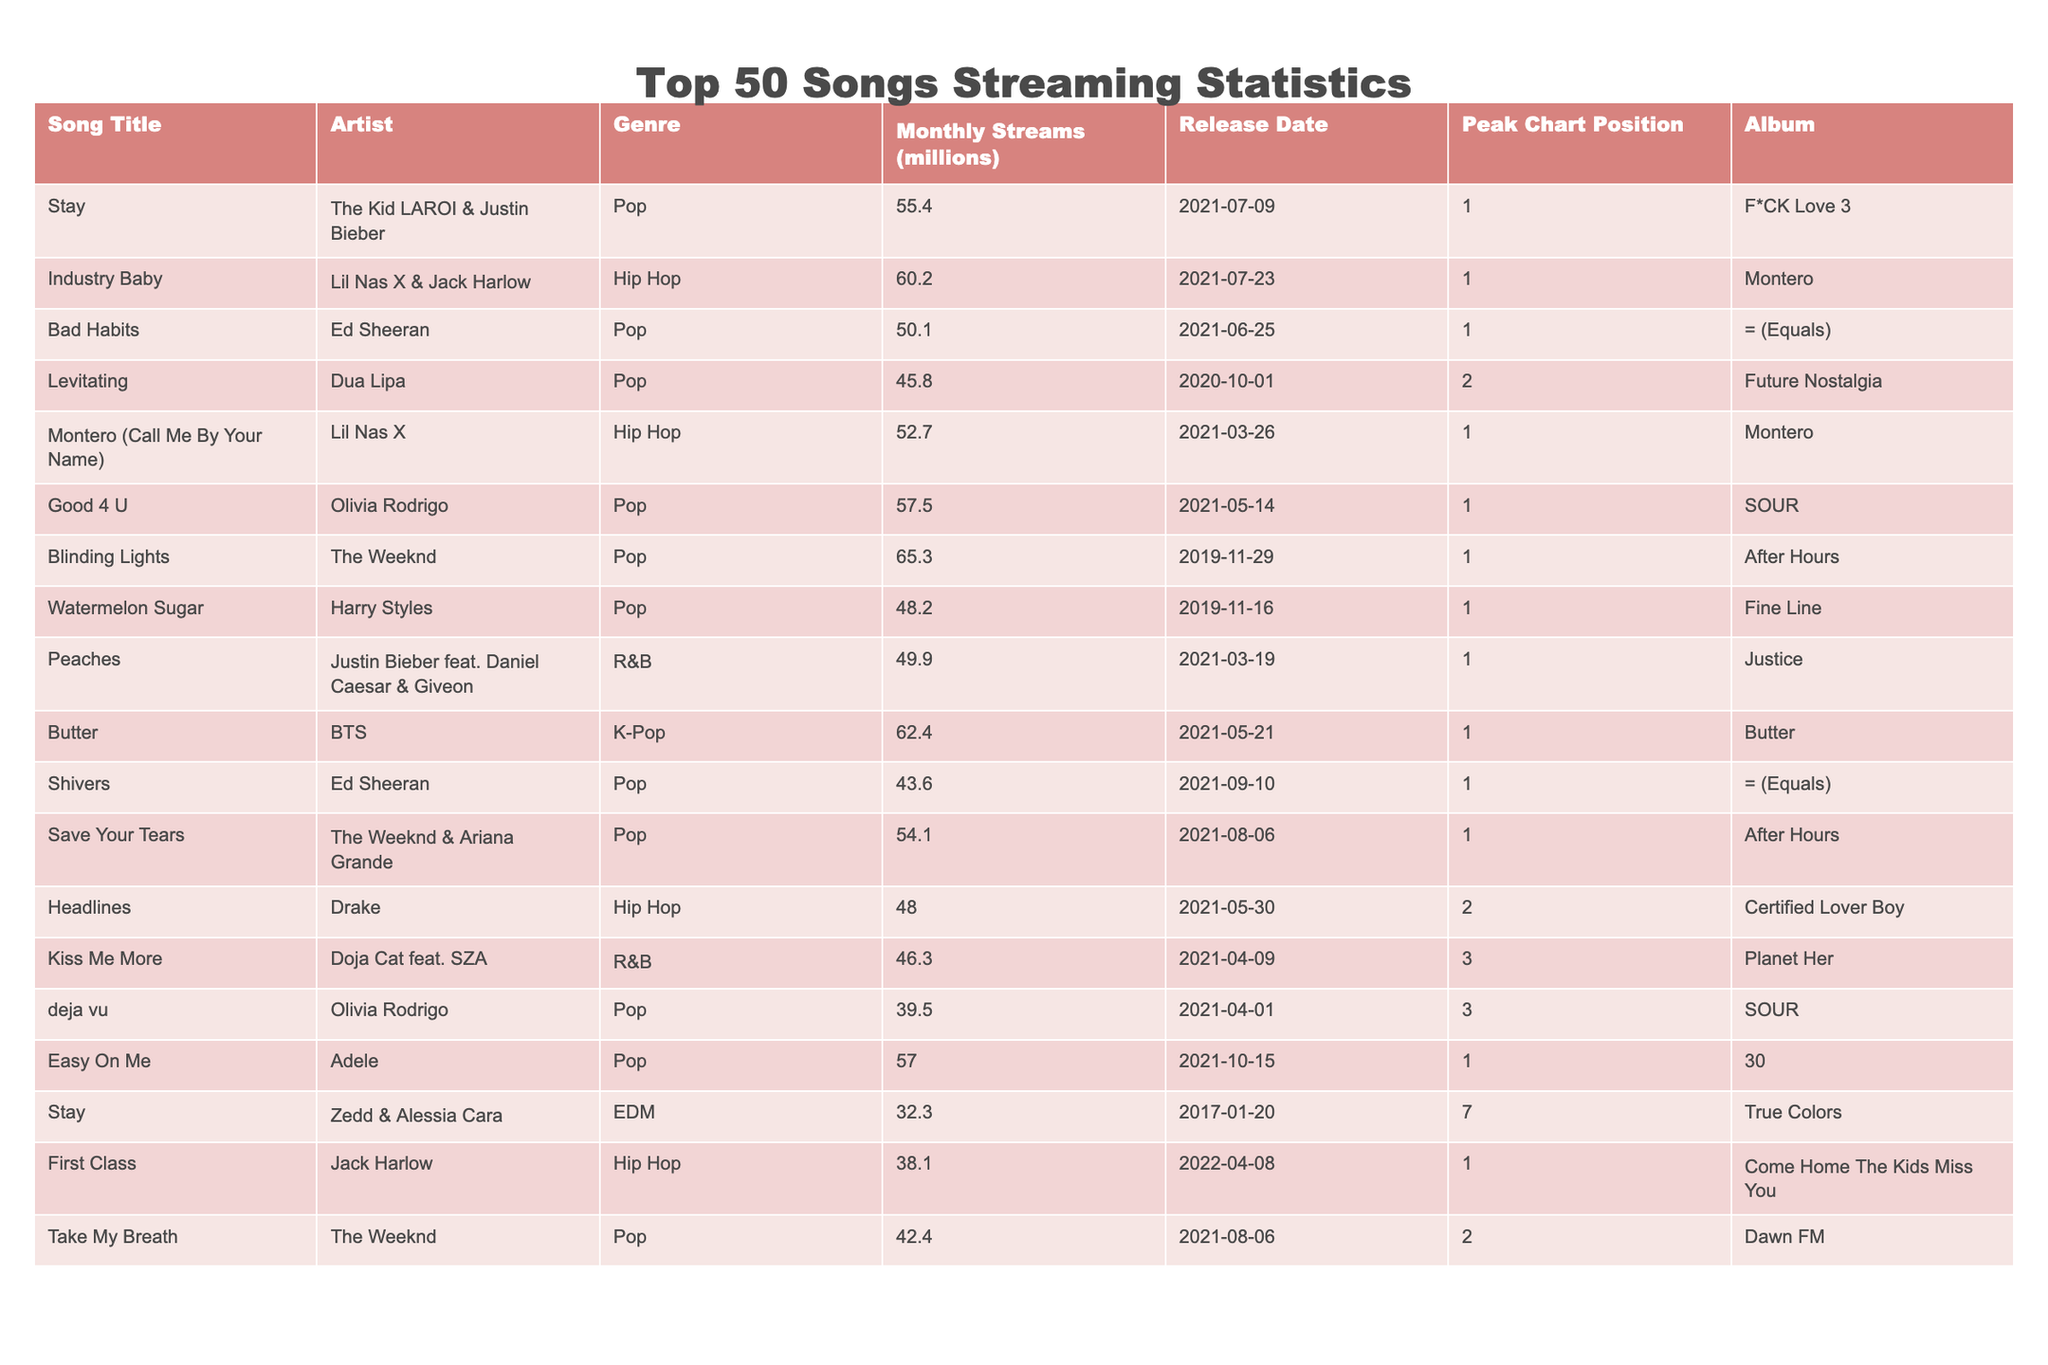What is the song with the highest monthly streams? By looking at the "Monthly Streams (millions)" column, the song "Blinding Lights" by The Weeknd has the highest value at 65.3 million streams.
Answer: Blinding Lights Which artist has the most songs in the top 50? By examining the "Artist" column, Ed Sheeran appears twice with the songs "Bad Habits" and "Shivers." Therefore, Ed Sheeran has the most entries among the listed artists.
Answer: Ed Sheeran What is the total monthly streams of all songs by Dua Lipa? Dua Lipa has one song in this list, "Levitating," with 45.8 million monthly streams. Since there is only one entry, the total monthly streams for Dua Lipa is simply 45.8.
Answer: 45.8 Which genre has the highest average monthly streams? To find the average monthly streams per genre, we will sum the monthly streams for each genre and divide by the number of songs in that genre. For example: Pop: (55.4 + 50.1 + 57.5 + 65.3 + 45.8 + 54.1 + 39.5 + 42.4) / 8 = 50.5 million; Hip Hop: (60.2 + 52.7 + 48) / 3 = 53.3 million; R&B: (49.9 + 46.3) / 2 = 48.1 million; K-Pop: 62.4. The average is highest for Pop at approximately 50.5 million.
Answer: Pop Is "Stay" by The Kid LAROI & Justin Bieber the only song titled "Stay" in this table? Upon checking the "Song Title" column, there are two instances of the song title "Stay": one by The Kid LAROI & Justin Bieber and another by Zedd & Alessia Cara. Thus, "Stay" is not unique to one artist in this table.
Answer: No 